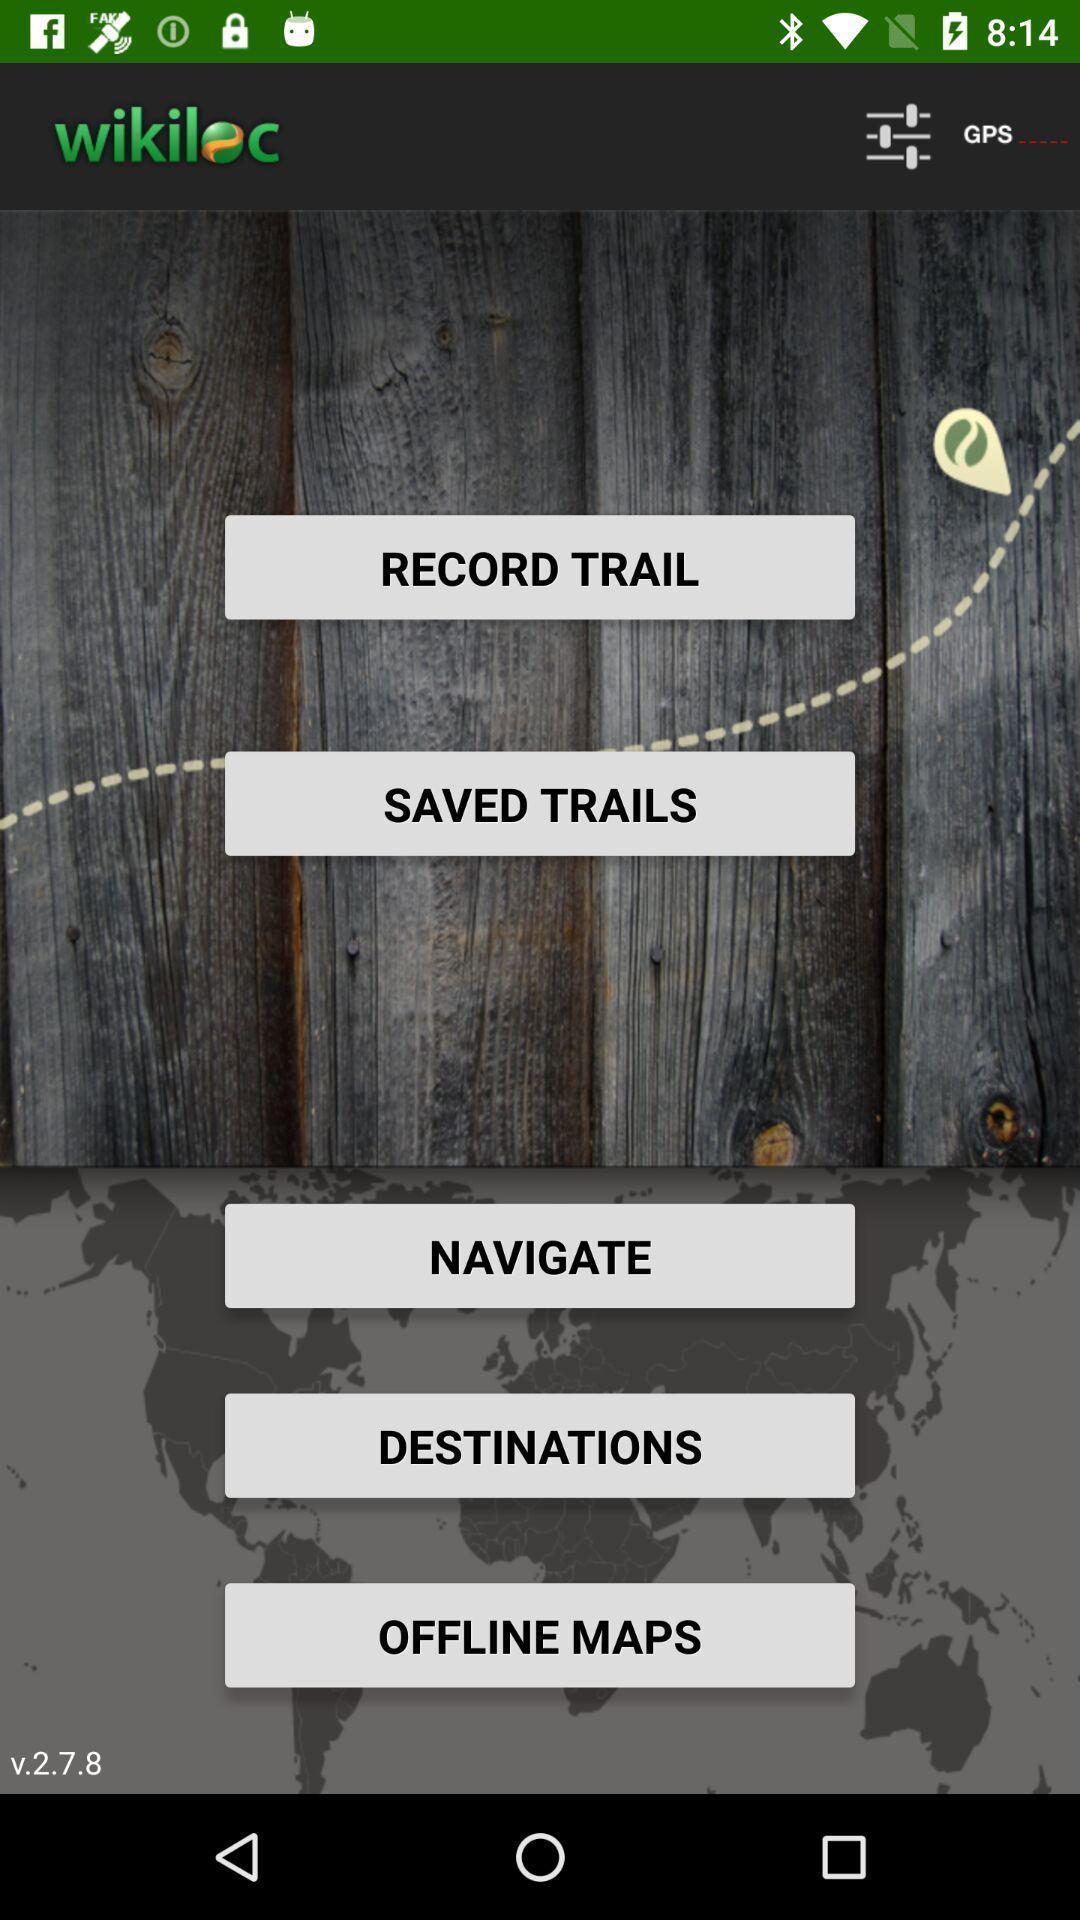Provide a textual representation of this image. Welcome page with multiple options for gps application. 